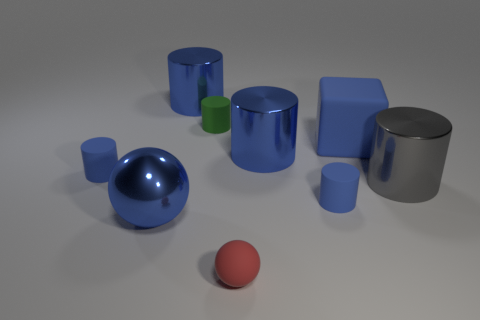How many blue cylinders must be subtracted to get 2 blue cylinders? 2 Subtract all blue metallic cylinders. How many cylinders are left? 4 Subtract all gray cylinders. How many cylinders are left? 5 Add 1 large brown things. How many objects exist? 10 Subtract all small balls. Subtract all gray metal objects. How many objects are left? 7 Add 2 big matte objects. How many big matte objects are left? 3 Add 1 matte things. How many matte things exist? 6 Subtract 0 red cylinders. How many objects are left? 9 Subtract all blocks. How many objects are left? 8 Subtract 2 cylinders. How many cylinders are left? 4 